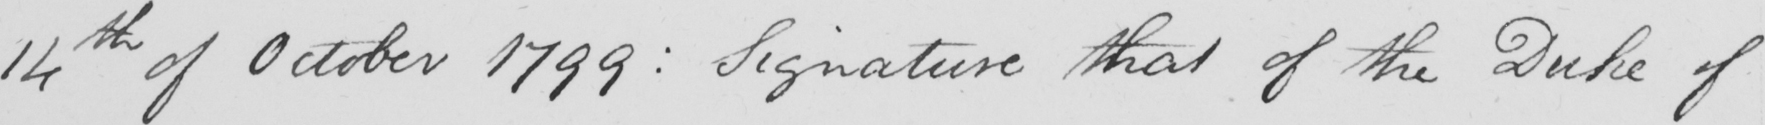Can you read and transcribe this handwriting? 14th of October 1799 :  Signature that of the Duke of 